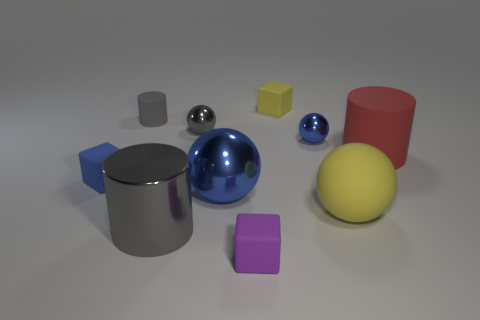What is the shape of the large metallic thing that is in front of the big yellow sphere?
Offer a terse response. Cylinder. Are the small gray sphere and the gray cylinder in front of the gray sphere made of the same material?
Make the answer very short. Yes. What number of other things are the same shape as the big red rubber thing?
Your response must be concise. 2. There is a metal cylinder; is its color the same as the matte cylinder that is to the left of the small gray shiny object?
Keep it short and to the point. Yes. Is there any other thing that has the same material as the purple cube?
Give a very brief answer. Yes. What is the shape of the gray metallic object that is behind the blue ball to the left of the small purple cube?
Offer a very short reply. Sphere. What size is the metallic ball that is the same color as the shiny cylinder?
Provide a short and direct response. Small. There is a gray shiny object in front of the large blue shiny sphere; does it have the same shape as the gray rubber thing?
Make the answer very short. Yes. Are there more large spheres that are in front of the gray metal cylinder than big metallic spheres that are to the right of the big yellow rubber object?
Give a very brief answer. No. How many big blue spheres are behind the tiny matte cube behind the tiny blue block?
Provide a short and direct response. 0. 